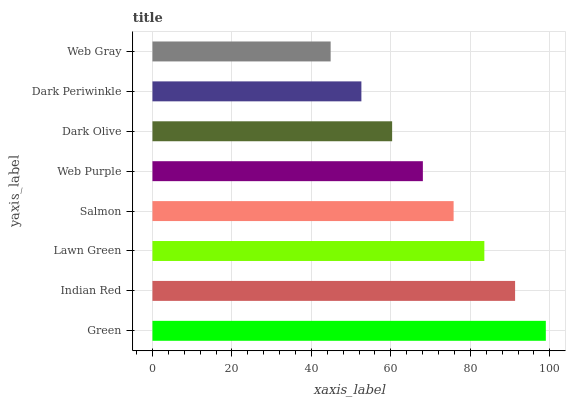Is Web Gray the minimum?
Answer yes or no. Yes. Is Green the maximum?
Answer yes or no. Yes. Is Indian Red the minimum?
Answer yes or no. No. Is Indian Red the maximum?
Answer yes or no. No. Is Green greater than Indian Red?
Answer yes or no. Yes. Is Indian Red less than Green?
Answer yes or no. Yes. Is Indian Red greater than Green?
Answer yes or no. No. Is Green less than Indian Red?
Answer yes or no. No. Is Salmon the high median?
Answer yes or no. Yes. Is Web Purple the low median?
Answer yes or no. Yes. Is Web Purple the high median?
Answer yes or no. No. Is Web Gray the low median?
Answer yes or no. No. 